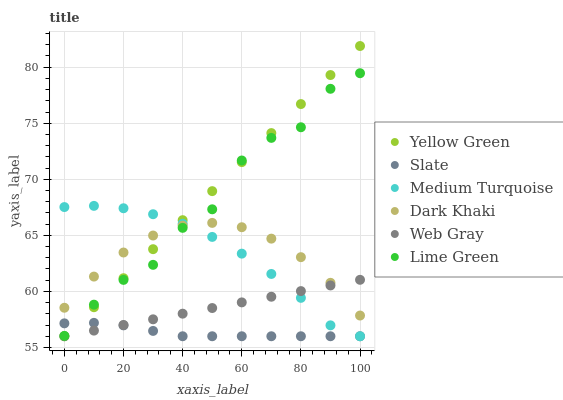Does Slate have the minimum area under the curve?
Answer yes or no. Yes. Does Yellow Green have the maximum area under the curve?
Answer yes or no. Yes. Does Yellow Green have the minimum area under the curve?
Answer yes or no. No. Does Slate have the maximum area under the curve?
Answer yes or no. No. Is Yellow Green the smoothest?
Answer yes or no. Yes. Is Lime Green the roughest?
Answer yes or no. Yes. Is Slate the smoothest?
Answer yes or no. No. Is Slate the roughest?
Answer yes or no. No. Does Web Gray have the lowest value?
Answer yes or no. Yes. Does Dark Khaki have the lowest value?
Answer yes or no. No. Does Yellow Green have the highest value?
Answer yes or no. Yes. Does Slate have the highest value?
Answer yes or no. No. Is Slate less than Dark Khaki?
Answer yes or no. Yes. Is Dark Khaki greater than Slate?
Answer yes or no. Yes. Does Yellow Green intersect Lime Green?
Answer yes or no. Yes. Is Yellow Green less than Lime Green?
Answer yes or no. No. Is Yellow Green greater than Lime Green?
Answer yes or no. No. Does Slate intersect Dark Khaki?
Answer yes or no. No. 